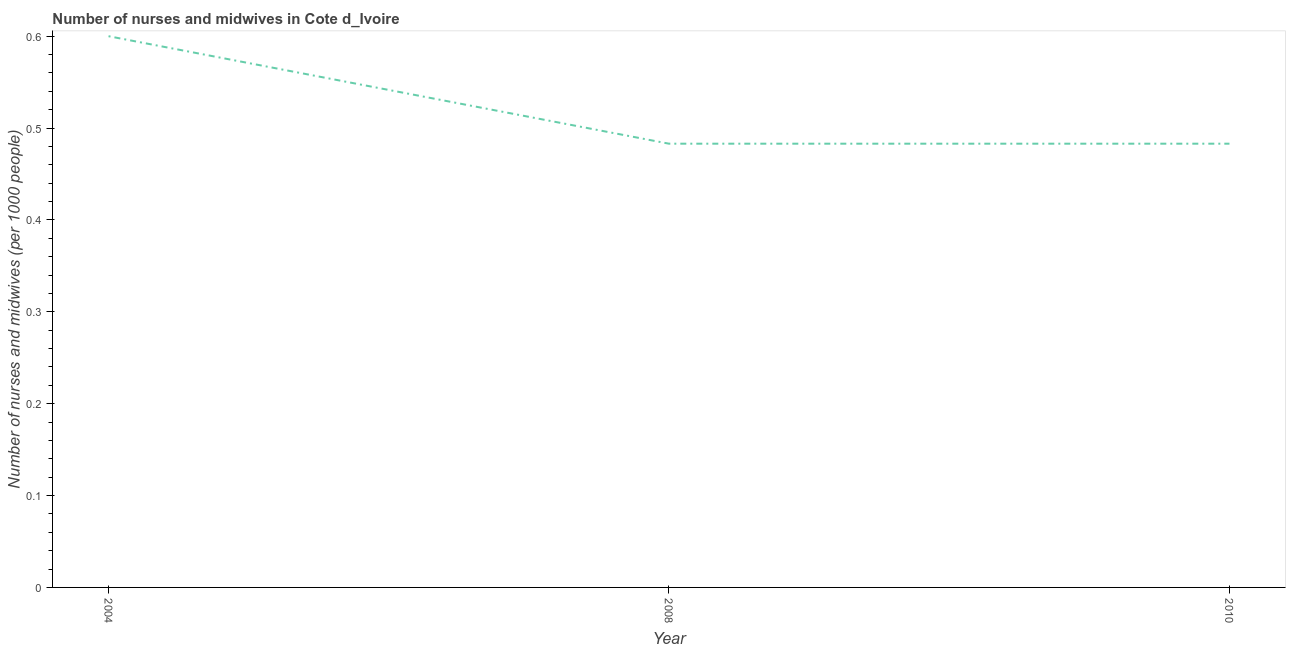What is the number of nurses and midwives in 2010?
Your answer should be compact. 0.48. Across all years, what is the minimum number of nurses and midwives?
Your answer should be very brief. 0.48. What is the sum of the number of nurses and midwives?
Provide a short and direct response. 1.57. What is the difference between the number of nurses and midwives in 2008 and 2010?
Keep it short and to the point. 0. What is the average number of nurses and midwives per year?
Your response must be concise. 0.52. What is the median number of nurses and midwives?
Ensure brevity in your answer.  0.48. In how many years, is the number of nurses and midwives greater than 0.36000000000000004 ?
Offer a terse response. 3. Is the difference between the number of nurses and midwives in 2004 and 2010 greater than the difference between any two years?
Your response must be concise. Yes. What is the difference between the highest and the second highest number of nurses and midwives?
Ensure brevity in your answer.  0.12. Is the sum of the number of nurses and midwives in 2008 and 2010 greater than the maximum number of nurses and midwives across all years?
Ensure brevity in your answer.  Yes. What is the difference between the highest and the lowest number of nurses and midwives?
Ensure brevity in your answer.  0.12. In how many years, is the number of nurses and midwives greater than the average number of nurses and midwives taken over all years?
Your answer should be very brief. 1. Does the graph contain any zero values?
Your response must be concise. No. Does the graph contain grids?
Your answer should be very brief. No. What is the title of the graph?
Offer a terse response. Number of nurses and midwives in Cote d_Ivoire. What is the label or title of the X-axis?
Keep it short and to the point. Year. What is the label or title of the Y-axis?
Your answer should be very brief. Number of nurses and midwives (per 1000 people). What is the Number of nurses and midwives (per 1000 people) in 2004?
Provide a succinct answer. 0.6. What is the Number of nurses and midwives (per 1000 people) in 2008?
Offer a very short reply. 0.48. What is the Number of nurses and midwives (per 1000 people) in 2010?
Offer a terse response. 0.48. What is the difference between the Number of nurses and midwives (per 1000 people) in 2004 and 2008?
Make the answer very short. 0.12. What is the difference between the Number of nurses and midwives (per 1000 people) in 2004 and 2010?
Your response must be concise. 0.12. What is the ratio of the Number of nurses and midwives (per 1000 people) in 2004 to that in 2008?
Offer a very short reply. 1.24. What is the ratio of the Number of nurses and midwives (per 1000 people) in 2004 to that in 2010?
Offer a terse response. 1.24. 